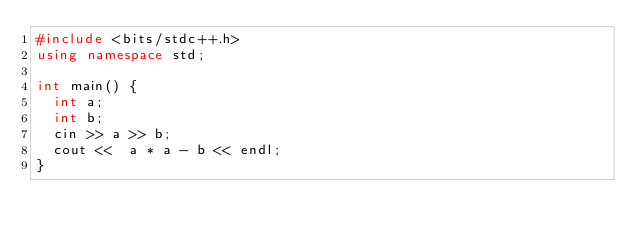<code> <loc_0><loc_0><loc_500><loc_500><_C++_>#include <bits/stdc++.h>
using namespace std;

int main() {
  int a;
  int b;
  cin >> a >> b;
  cout <<  a * a - b << endl;
}
</code> 